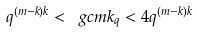<formula> <loc_0><loc_0><loc_500><loc_500>q ^ { ( m - k ) k } < \ g c { m } { k } _ { q } < 4 q ^ { ( m - k ) k }</formula> 